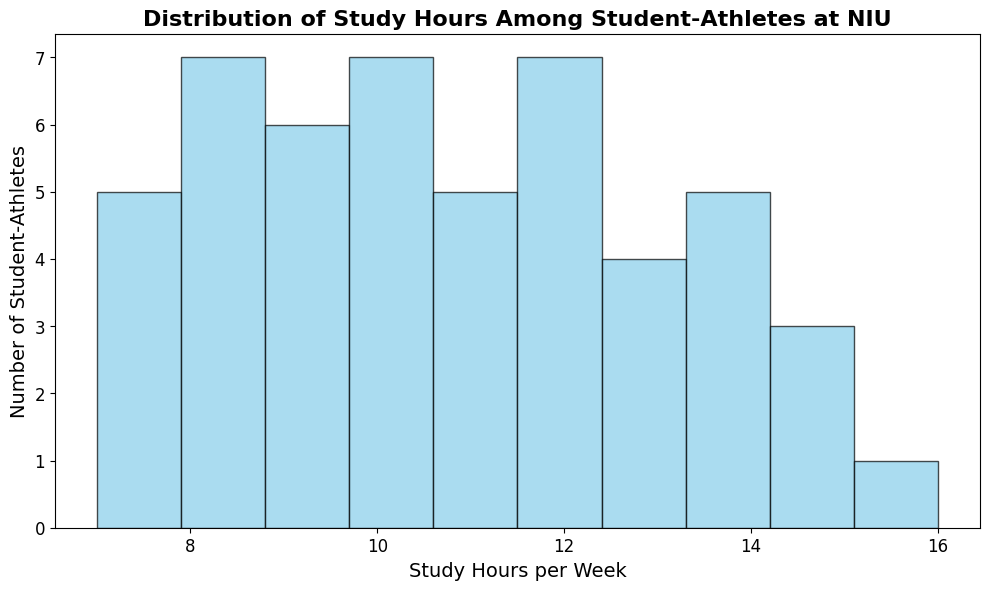How many student-athletes study between 8 and 12 hours per week? Identify all the bars within the range of 8 to 12 hours on the x-axis, then count the total number of student-athletes for these bins.
Answer: 29 What is the most common range of study hours per week among student-athletes? Look for the tallest bar(s) in the histogram, which indicates the most frequent range of study hours.
Answer: 12-13 hours How many student-athletes study less than 10 hours per week? Add the heights of the bars for all ranges below 10 on the x-axis.
Answer: 19 What is the difference between the number of student-athletes who study 14-16 hours and those who study 7-9 hours per week? Count the number of student-athletes in the 14-16 hours range and subtract the count from the 7-9 hours range.
Answer: 2 Is there a greater number of student-athletes who study exactly 10 hours per week or those who study exactly 12 hours per week? Compare the height of the bars at the 10-hour and 12-hour marks.
Answer: both are equal What is the total number of student-athletes who study 13 hours or more per week? Add the heights of the bars for all ranges 13 hours and above.
Answer: 15 How does the number of student-athletes studying 11-13 hours compare to those studying 7-9 hours per week? Add the counts of student-athletes from 11-13 hours range and compare it to the sum of the 7-9 hours range.
Answer: 21 vs 19, more Which range of study hours has the least number of student-athletes? Identify the shortest bar in the histogram, indicating the range with the fewest student-athletes.
Answer: 16 hours What is the mean study hour for student-athletes shown in the histogram? Calculate the mean by multiplying the midpoints of each bin by its respective count, summing these products, then dividing by the total number of student-athletes.
Answer: 10.98 hours Which study hour range is more frequent: 8-9 hours or 14-16 hours? Compare the total heights of the bars in the 8-9 hours range to the total in the 14-16 hours range.
Answer: 8-9 hours 